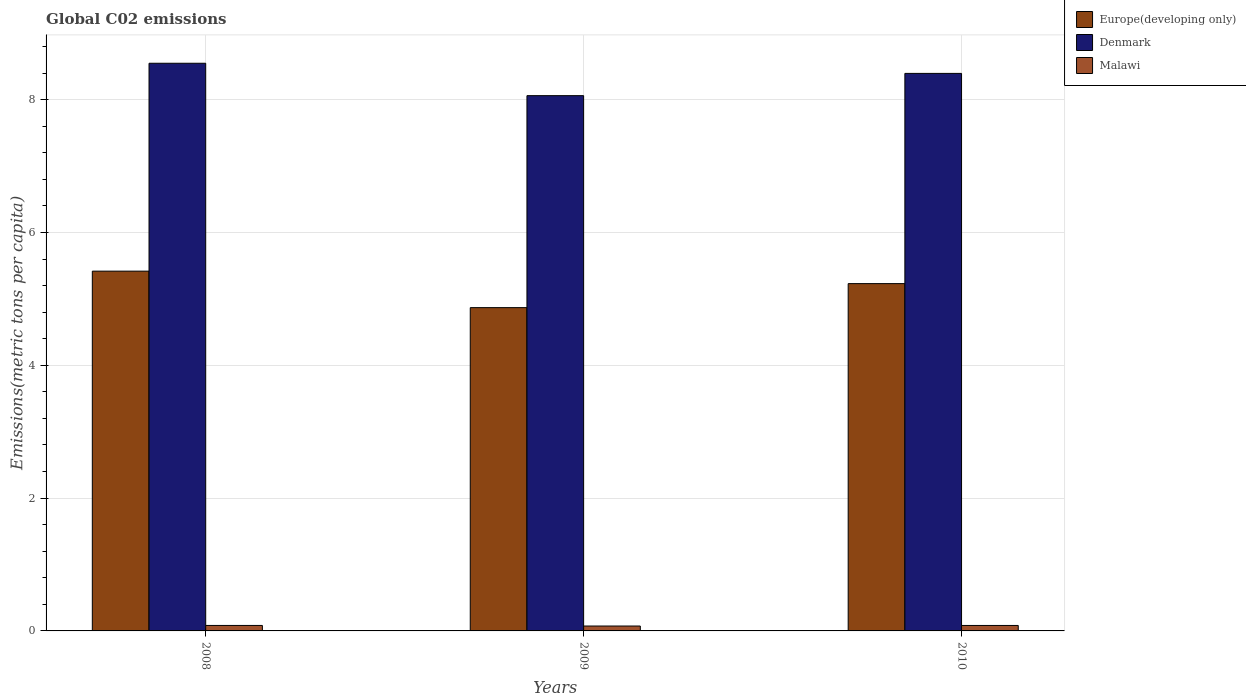Are the number of bars per tick equal to the number of legend labels?
Your response must be concise. Yes. How many bars are there on the 1st tick from the left?
Keep it short and to the point. 3. How many bars are there on the 1st tick from the right?
Offer a very short reply. 3. What is the amount of CO2 emitted in in Denmark in 2010?
Provide a succinct answer. 8.39. Across all years, what is the maximum amount of CO2 emitted in in Malawi?
Your answer should be compact. 0.08. Across all years, what is the minimum amount of CO2 emitted in in Europe(developing only)?
Give a very brief answer. 4.87. What is the total amount of CO2 emitted in in Europe(developing only) in the graph?
Provide a short and direct response. 15.51. What is the difference between the amount of CO2 emitted in in Europe(developing only) in 2008 and that in 2010?
Your answer should be very brief. 0.19. What is the difference between the amount of CO2 emitted in in Europe(developing only) in 2010 and the amount of CO2 emitted in in Denmark in 2009?
Give a very brief answer. -2.83. What is the average amount of CO2 emitted in in Europe(developing only) per year?
Provide a short and direct response. 5.17. In the year 2010, what is the difference between the amount of CO2 emitted in in Malawi and amount of CO2 emitted in in Europe(developing only)?
Your answer should be very brief. -5.15. What is the ratio of the amount of CO2 emitted in in Denmark in 2009 to that in 2010?
Provide a succinct answer. 0.96. Is the difference between the amount of CO2 emitted in in Malawi in 2009 and 2010 greater than the difference between the amount of CO2 emitted in in Europe(developing only) in 2009 and 2010?
Keep it short and to the point. Yes. What is the difference between the highest and the second highest amount of CO2 emitted in in Denmark?
Provide a succinct answer. 0.15. What is the difference between the highest and the lowest amount of CO2 emitted in in Europe(developing only)?
Your answer should be very brief. 0.55. In how many years, is the amount of CO2 emitted in in Malawi greater than the average amount of CO2 emitted in in Malawi taken over all years?
Provide a short and direct response. 2. Is the sum of the amount of CO2 emitted in in Denmark in 2008 and 2010 greater than the maximum amount of CO2 emitted in in Malawi across all years?
Give a very brief answer. Yes. What does the 1st bar from the left in 2008 represents?
Provide a succinct answer. Europe(developing only). What does the 1st bar from the right in 2009 represents?
Keep it short and to the point. Malawi. Is it the case that in every year, the sum of the amount of CO2 emitted in in Europe(developing only) and amount of CO2 emitted in in Denmark is greater than the amount of CO2 emitted in in Malawi?
Offer a terse response. Yes. How many bars are there?
Offer a very short reply. 9. Are all the bars in the graph horizontal?
Your answer should be very brief. No. Does the graph contain any zero values?
Make the answer very short. No. Does the graph contain grids?
Give a very brief answer. Yes. What is the title of the graph?
Give a very brief answer. Global C02 emissions. Does "Denmark" appear as one of the legend labels in the graph?
Your answer should be compact. Yes. What is the label or title of the Y-axis?
Ensure brevity in your answer.  Emissions(metric tons per capita). What is the Emissions(metric tons per capita) in Europe(developing only) in 2008?
Provide a succinct answer. 5.42. What is the Emissions(metric tons per capita) of Denmark in 2008?
Provide a succinct answer. 8.55. What is the Emissions(metric tons per capita) of Malawi in 2008?
Offer a terse response. 0.08. What is the Emissions(metric tons per capita) in Europe(developing only) in 2009?
Offer a very short reply. 4.87. What is the Emissions(metric tons per capita) of Denmark in 2009?
Offer a terse response. 8.06. What is the Emissions(metric tons per capita) of Malawi in 2009?
Make the answer very short. 0.07. What is the Emissions(metric tons per capita) in Europe(developing only) in 2010?
Your response must be concise. 5.23. What is the Emissions(metric tons per capita) in Denmark in 2010?
Offer a terse response. 8.39. What is the Emissions(metric tons per capita) in Malawi in 2010?
Provide a short and direct response. 0.08. Across all years, what is the maximum Emissions(metric tons per capita) of Europe(developing only)?
Provide a short and direct response. 5.42. Across all years, what is the maximum Emissions(metric tons per capita) in Denmark?
Provide a succinct answer. 8.55. Across all years, what is the maximum Emissions(metric tons per capita) in Malawi?
Keep it short and to the point. 0.08. Across all years, what is the minimum Emissions(metric tons per capita) in Europe(developing only)?
Your answer should be very brief. 4.87. Across all years, what is the minimum Emissions(metric tons per capita) in Denmark?
Keep it short and to the point. 8.06. Across all years, what is the minimum Emissions(metric tons per capita) in Malawi?
Offer a very short reply. 0.07. What is the total Emissions(metric tons per capita) in Europe(developing only) in the graph?
Your answer should be compact. 15.51. What is the total Emissions(metric tons per capita) in Denmark in the graph?
Make the answer very short. 25. What is the total Emissions(metric tons per capita) in Malawi in the graph?
Your response must be concise. 0.24. What is the difference between the Emissions(metric tons per capita) in Europe(developing only) in 2008 and that in 2009?
Ensure brevity in your answer.  0.55. What is the difference between the Emissions(metric tons per capita) of Denmark in 2008 and that in 2009?
Offer a very short reply. 0.49. What is the difference between the Emissions(metric tons per capita) in Malawi in 2008 and that in 2009?
Your response must be concise. 0.01. What is the difference between the Emissions(metric tons per capita) of Europe(developing only) in 2008 and that in 2010?
Give a very brief answer. 0.19. What is the difference between the Emissions(metric tons per capita) in Denmark in 2008 and that in 2010?
Ensure brevity in your answer.  0.15. What is the difference between the Emissions(metric tons per capita) of Malawi in 2008 and that in 2010?
Make the answer very short. 0. What is the difference between the Emissions(metric tons per capita) in Europe(developing only) in 2009 and that in 2010?
Offer a terse response. -0.36. What is the difference between the Emissions(metric tons per capita) in Denmark in 2009 and that in 2010?
Ensure brevity in your answer.  -0.34. What is the difference between the Emissions(metric tons per capita) of Malawi in 2009 and that in 2010?
Ensure brevity in your answer.  -0.01. What is the difference between the Emissions(metric tons per capita) of Europe(developing only) in 2008 and the Emissions(metric tons per capita) of Denmark in 2009?
Your answer should be compact. -2.64. What is the difference between the Emissions(metric tons per capita) in Europe(developing only) in 2008 and the Emissions(metric tons per capita) in Malawi in 2009?
Offer a very short reply. 5.34. What is the difference between the Emissions(metric tons per capita) in Denmark in 2008 and the Emissions(metric tons per capita) in Malawi in 2009?
Your answer should be compact. 8.47. What is the difference between the Emissions(metric tons per capita) in Europe(developing only) in 2008 and the Emissions(metric tons per capita) in Denmark in 2010?
Offer a terse response. -2.98. What is the difference between the Emissions(metric tons per capita) of Europe(developing only) in 2008 and the Emissions(metric tons per capita) of Malawi in 2010?
Offer a terse response. 5.33. What is the difference between the Emissions(metric tons per capita) in Denmark in 2008 and the Emissions(metric tons per capita) in Malawi in 2010?
Your answer should be compact. 8.47. What is the difference between the Emissions(metric tons per capita) in Europe(developing only) in 2009 and the Emissions(metric tons per capita) in Denmark in 2010?
Provide a short and direct response. -3.53. What is the difference between the Emissions(metric tons per capita) in Europe(developing only) in 2009 and the Emissions(metric tons per capita) in Malawi in 2010?
Ensure brevity in your answer.  4.79. What is the difference between the Emissions(metric tons per capita) of Denmark in 2009 and the Emissions(metric tons per capita) of Malawi in 2010?
Offer a very short reply. 7.98. What is the average Emissions(metric tons per capita) in Europe(developing only) per year?
Make the answer very short. 5.17. What is the average Emissions(metric tons per capita) of Denmark per year?
Ensure brevity in your answer.  8.33. What is the average Emissions(metric tons per capita) in Malawi per year?
Offer a terse response. 0.08. In the year 2008, what is the difference between the Emissions(metric tons per capita) in Europe(developing only) and Emissions(metric tons per capita) in Denmark?
Your answer should be compact. -3.13. In the year 2008, what is the difference between the Emissions(metric tons per capita) of Europe(developing only) and Emissions(metric tons per capita) of Malawi?
Offer a very short reply. 5.33. In the year 2008, what is the difference between the Emissions(metric tons per capita) in Denmark and Emissions(metric tons per capita) in Malawi?
Offer a terse response. 8.46. In the year 2009, what is the difference between the Emissions(metric tons per capita) in Europe(developing only) and Emissions(metric tons per capita) in Denmark?
Ensure brevity in your answer.  -3.19. In the year 2009, what is the difference between the Emissions(metric tons per capita) of Europe(developing only) and Emissions(metric tons per capita) of Malawi?
Offer a terse response. 4.79. In the year 2009, what is the difference between the Emissions(metric tons per capita) in Denmark and Emissions(metric tons per capita) in Malawi?
Give a very brief answer. 7.99. In the year 2010, what is the difference between the Emissions(metric tons per capita) of Europe(developing only) and Emissions(metric tons per capita) of Denmark?
Give a very brief answer. -3.17. In the year 2010, what is the difference between the Emissions(metric tons per capita) in Europe(developing only) and Emissions(metric tons per capita) in Malawi?
Make the answer very short. 5.15. In the year 2010, what is the difference between the Emissions(metric tons per capita) in Denmark and Emissions(metric tons per capita) in Malawi?
Ensure brevity in your answer.  8.31. What is the ratio of the Emissions(metric tons per capita) of Europe(developing only) in 2008 to that in 2009?
Provide a short and direct response. 1.11. What is the ratio of the Emissions(metric tons per capita) of Denmark in 2008 to that in 2009?
Ensure brevity in your answer.  1.06. What is the ratio of the Emissions(metric tons per capita) in Malawi in 2008 to that in 2009?
Keep it short and to the point. 1.12. What is the ratio of the Emissions(metric tons per capita) of Europe(developing only) in 2008 to that in 2010?
Give a very brief answer. 1.04. What is the ratio of the Emissions(metric tons per capita) in Denmark in 2008 to that in 2010?
Your answer should be compact. 1.02. What is the ratio of the Emissions(metric tons per capita) in Europe(developing only) in 2009 to that in 2010?
Give a very brief answer. 0.93. What is the ratio of the Emissions(metric tons per capita) in Denmark in 2009 to that in 2010?
Keep it short and to the point. 0.96. What is the ratio of the Emissions(metric tons per capita) of Malawi in 2009 to that in 2010?
Your response must be concise. 0.9. What is the difference between the highest and the second highest Emissions(metric tons per capita) of Europe(developing only)?
Provide a succinct answer. 0.19. What is the difference between the highest and the second highest Emissions(metric tons per capita) of Denmark?
Ensure brevity in your answer.  0.15. What is the difference between the highest and the second highest Emissions(metric tons per capita) of Malawi?
Provide a short and direct response. 0. What is the difference between the highest and the lowest Emissions(metric tons per capita) of Europe(developing only)?
Ensure brevity in your answer.  0.55. What is the difference between the highest and the lowest Emissions(metric tons per capita) of Denmark?
Offer a very short reply. 0.49. What is the difference between the highest and the lowest Emissions(metric tons per capita) in Malawi?
Keep it short and to the point. 0.01. 